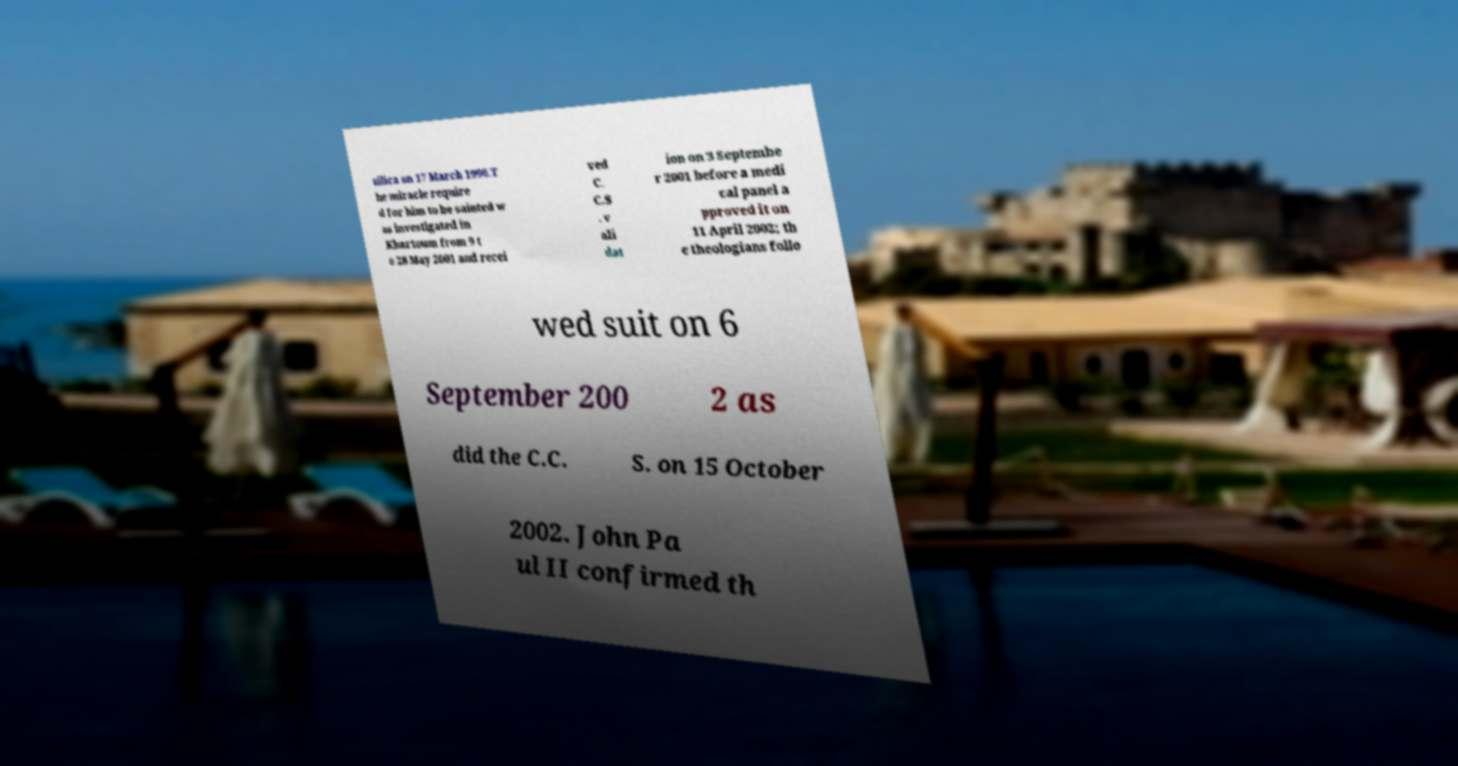Can you accurately transcribe the text from the provided image for me? silica on 17 March 1996.T he miracle require d for him to be sainted w as investigated in Khartoum from 9 t o 28 May 2001 and recei ved C. C.S . v ali dat ion on 3 Septembe r 2001 before a medi cal panel a pproved it on 11 April 2002; th e theologians follo wed suit on 6 September 200 2 as did the C.C. S. on 15 October 2002. John Pa ul II confirmed th 